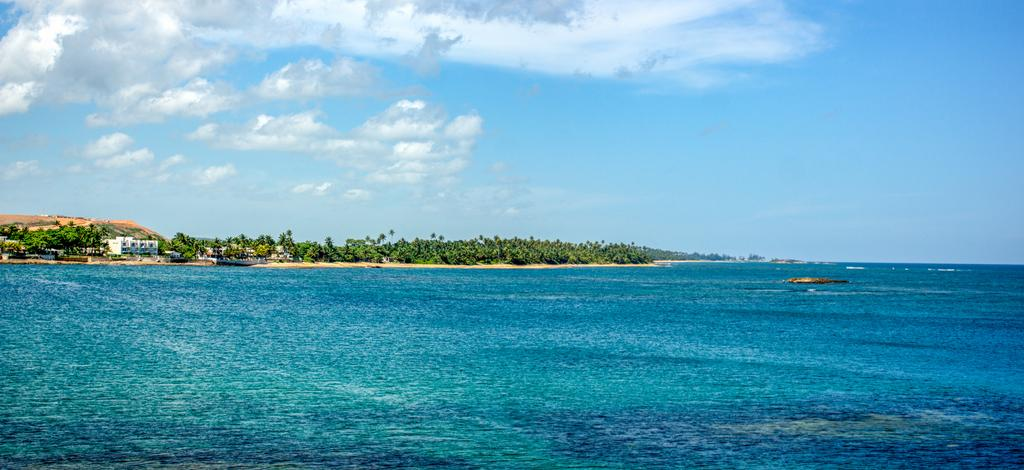What is the primary element visible in the image? There is water in the image. What can be seen in the distance behind the water? There are trees and buildings in the background of the image. What is visible in the sky in the image? There are clouds visible in the background of the image. What type of behavior can be observed in the kite flying over the water in the image? There is no kite present in the image, so no behavior can be observed. 